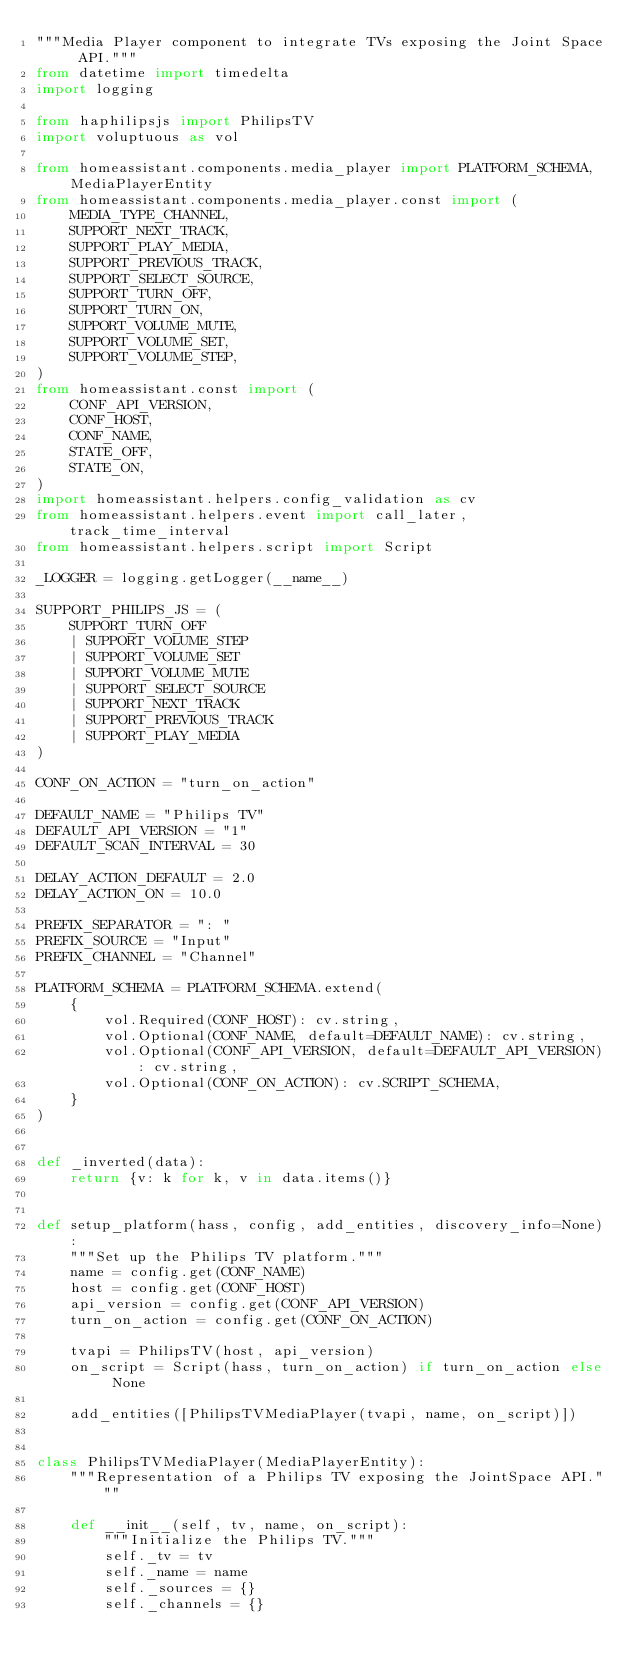<code> <loc_0><loc_0><loc_500><loc_500><_Python_>"""Media Player component to integrate TVs exposing the Joint Space API."""
from datetime import timedelta
import logging

from haphilipsjs import PhilipsTV
import voluptuous as vol

from homeassistant.components.media_player import PLATFORM_SCHEMA, MediaPlayerEntity
from homeassistant.components.media_player.const import (
    MEDIA_TYPE_CHANNEL,
    SUPPORT_NEXT_TRACK,
    SUPPORT_PLAY_MEDIA,
    SUPPORT_PREVIOUS_TRACK,
    SUPPORT_SELECT_SOURCE,
    SUPPORT_TURN_OFF,
    SUPPORT_TURN_ON,
    SUPPORT_VOLUME_MUTE,
    SUPPORT_VOLUME_SET,
    SUPPORT_VOLUME_STEP,
)
from homeassistant.const import (
    CONF_API_VERSION,
    CONF_HOST,
    CONF_NAME,
    STATE_OFF,
    STATE_ON,
)
import homeassistant.helpers.config_validation as cv
from homeassistant.helpers.event import call_later, track_time_interval
from homeassistant.helpers.script import Script

_LOGGER = logging.getLogger(__name__)

SUPPORT_PHILIPS_JS = (
    SUPPORT_TURN_OFF
    | SUPPORT_VOLUME_STEP
    | SUPPORT_VOLUME_SET
    | SUPPORT_VOLUME_MUTE
    | SUPPORT_SELECT_SOURCE
    | SUPPORT_NEXT_TRACK
    | SUPPORT_PREVIOUS_TRACK
    | SUPPORT_PLAY_MEDIA
)

CONF_ON_ACTION = "turn_on_action"

DEFAULT_NAME = "Philips TV"
DEFAULT_API_VERSION = "1"
DEFAULT_SCAN_INTERVAL = 30

DELAY_ACTION_DEFAULT = 2.0
DELAY_ACTION_ON = 10.0

PREFIX_SEPARATOR = ": "
PREFIX_SOURCE = "Input"
PREFIX_CHANNEL = "Channel"

PLATFORM_SCHEMA = PLATFORM_SCHEMA.extend(
    {
        vol.Required(CONF_HOST): cv.string,
        vol.Optional(CONF_NAME, default=DEFAULT_NAME): cv.string,
        vol.Optional(CONF_API_VERSION, default=DEFAULT_API_VERSION): cv.string,
        vol.Optional(CONF_ON_ACTION): cv.SCRIPT_SCHEMA,
    }
)


def _inverted(data):
    return {v: k for k, v in data.items()}


def setup_platform(hass, config, add_entities, discovery_info=None):
    """Set up the Philips TV platform."""
    name = config.get(CONF_NAME)
    host = config.get(CONF_HOST)
    api_version = config.get(CONF_API_VERSION)
    turn_on_action = config.get(CONF_ON_ACTION)

    tvapi = PhilipsTV(host, api_version)
    on_script = Script(hass, turn_on_action) if turn_on_action else None

    add_entities([PhilipsTVMediaPlayer(tvapi, name, on_script)])


class PhilipsTVMediaPlayer(MediaPlayerEntity):
    """Representation of a Philips TV exposing the JointSpace API."""

    def __init__(self, tv, name, on_script):
        """Initialize the Philips TV."""
        self._tv = tv
        self._name = name
        self._sources = {}
        self._channels = {}</code> 